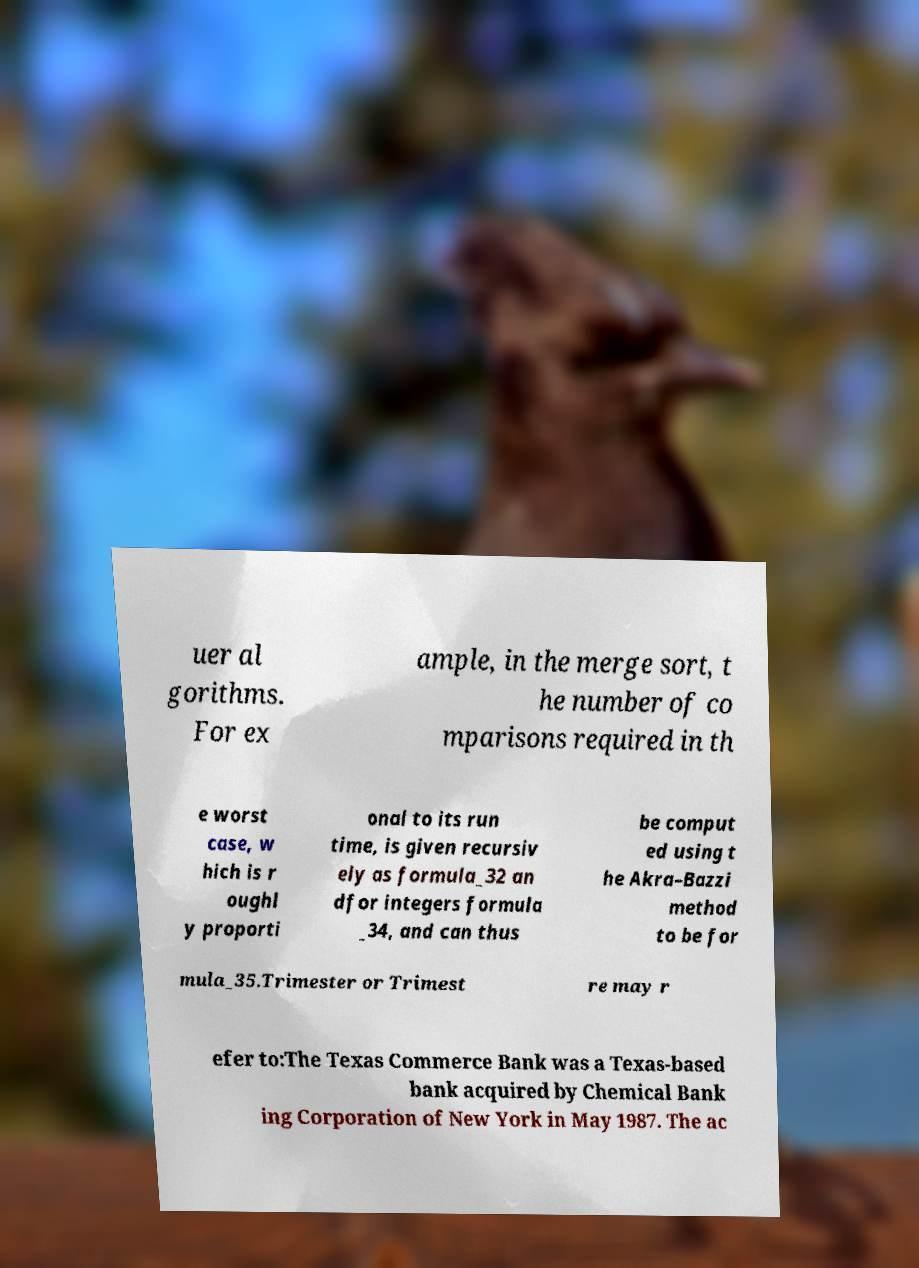What messages or text are displayed in this image? I need them in a readable, typed format. uer al gorithms. For ex ample, in the merge sort, t he number of co mparisons required in th e worst case, w hich is r oughl y proporti onal to its run time, is given recursiv ely as formula_32 an dfor integers formula _34, and can thus be comput ed using t he Akra–Bazzi method to be for mula_35.Trimester or Trimest re may r efer to:The Texas Commerce Bank was a Texas-based bank acquired by Chemical Bank ing Corporation of New York in May 1987. The ac 